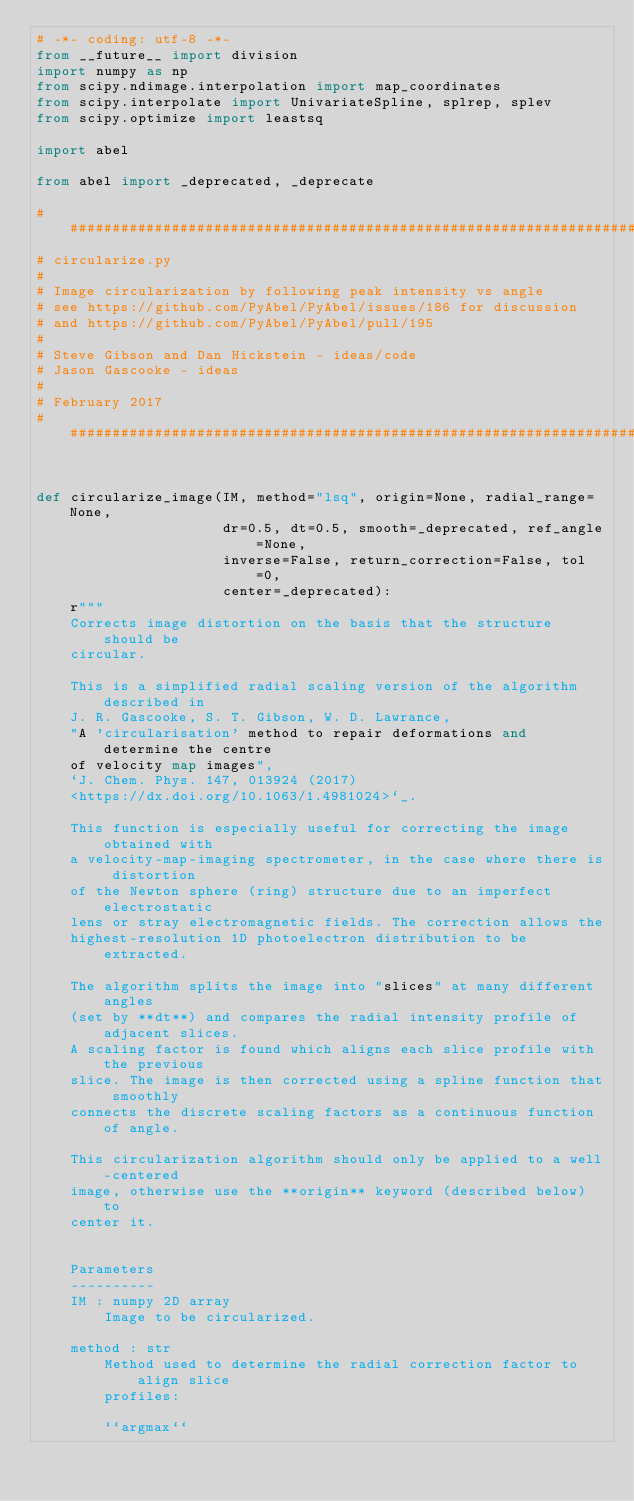Convert code to text. <code><loc_0><loc_0><loc_500><loc_500><_Python_># -*- coding: utf-8 -*-
from __future__ import division
import numpy as np
from scipy.ndimage.interpolation import map_coordinates
from scipy.interpolate import UnivariateSpline, splrep, splev
from scipy.optimize import leastsq

import abel

from abel import _deprecated, _deprecate

#########################################################################
# circularize.py
#
# Image circularization by following peak intensity vs angle
# see https://github.com/PyAbel/PyAbel/issues/186 for discussion
# and https://github.com/PyAbel/PyAbel/pull/195
#
# Steve Gibson and Dan Hickstein - ideas/code
# Jason Gascooke - ideas
#
# February 2017
#########################################################################


def circularize_image(IM, method="lsq", origin=None, radial_range=None,
                      dr=0.5, dt=0.5, smooth=_deprecated, ref_angle=None,
                      inverse=False, return_correction=False, tol=0,
                      center=_deprecated):
    r"""
    Corrects image distortion on the basis that the structure should be
    circular.

    This is a simplified radial scaling version of the algorithm described in
    J. R. Gascooke, S. T. Gibson, W. D. Lawrance,
    "A 'circularisation' method to repair deformations and determine the centre
    of velocity map images",
    `J. Chem. Phys. 147, 013924 (2017)
    <https://dx.doi.org/10.1063/1.4981024>`_.

    This function is especially useful for correcting the image obtained with
    a velocity-map-imaging spectrometer, in the case where there is distortion
    of the Newton sphere (ring) structure due to an imperfect electrostatic
    lens or stray electromagnetic fields. The correction allows the
    highest-resolution 1D photoelectron distribution to be extracted.

    The algorithm splits the image into "slices" at many different angles
    (set by **dt**) and compares the radial intensity profile of adjacent slices.
    A scaling factor is found which aligns each slice profile with the previous
    slice. The image is then corrected using a spline function that smoothly
    connects the discrete scaling factors as a continuous function of angle.

    This circularization algorithm should only be applied to a well-centered
    image, otherwise use the **origin** keyword (described below) to
    center it.


    Parameters
    ----------
    IM : numpy 2D array
        Image to be circularized.

    method : str
        Method used to determine the radial correction factor to align slice
        profiles:

        ``argmax``</code> 